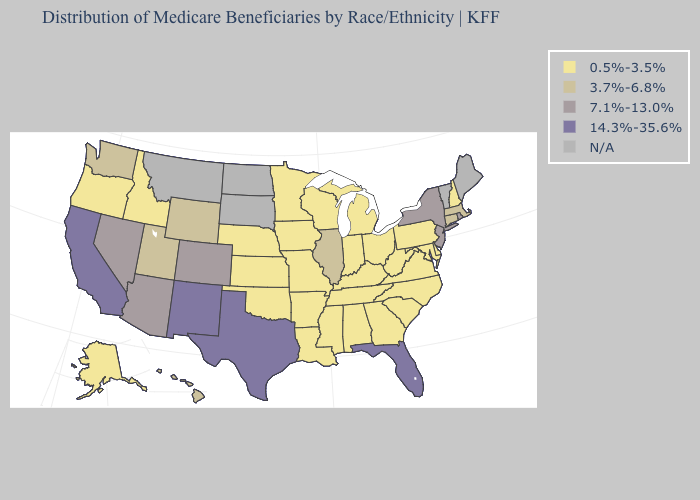What is the value of New York?
Concise answer only. 7.1%-13.0%. Among the states that border Ohio , which have the highest value?
Keep it brief. Indiana, Kentucky, Michigan, Pennsylvania, West Virginia. What is the value of Maine?
Concise answer only. N/A. Which states have the lowest value in the USA?
Keep it brief. Alabama, Alaska, Arkansas, Delaware, Georgia, Idaho, Indiana, Iowa, Kansas, Kentucky, Louisiana, Maryland, Michigan, Minnesota, Mississippi, Missouri, Nebraska, New Hampshire, North Carolina, Ohio, Oklahoma, Oregon, Pennsylvania, South Carolina, Tennessee, Virginia, West Virginia, Wisconsin. Which states hav the highest value in the South?
Give a very brief answer. Florida, Texas. Does Missouri have the lowest value in the USA?
Give a very brief answer. Yes. Does Illinois have the highest value in the MidWest?
Keep it brief. Yes. Which states have the lowest value in the USA?
Concise answer only. Alabama, Alaska, Arkansas, Delaware, Georgia, Idaho, Indiana, Iowa, Kansas, Kentucky, Louisiana, Maryland, Michigan, Minnesota, Mississippi, Missouri, Nebraska, New Hampshire, North Carolina, Ohio, Oklahoma, Oregon, Pennsylvania, South Carolina, Tennessee, Virginia, West Virginia, Wisconsin. Name the states that have a value in the range N/A?
Answer briefly. Maine, Montana, North Dakota, South Dakota, Vermont. Which states hav the highest value in the MidWest?
Write a very short answer. Illinois. What is the value of Florida?
Concise answer only. 14.3%-35.6%. Name the states that have a value in the range 3.7%-6.8%?
Quick response, please. Connecticut, Hawaii, Illinois, Massachusetts, Utah, Washington, Wyoming. 